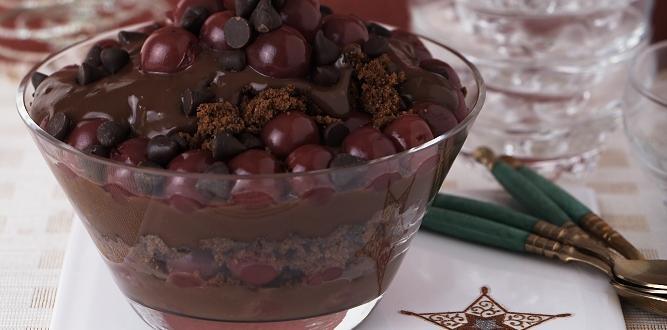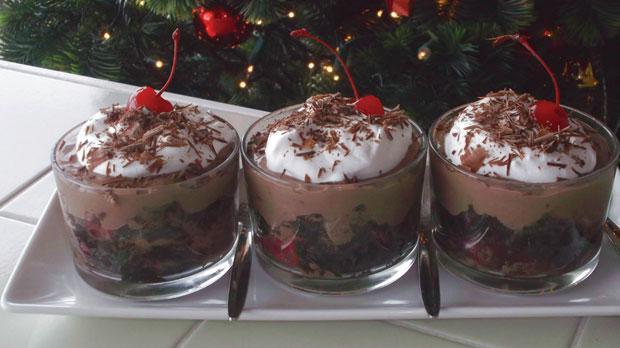The first image is the image on the left, the second image is the image on the right. Given the left and right images, does the statement "In the right image, there are at least three chocolate deserts." hold true? Answer yes or no. Yes. The first image is the image on the left, the second image is the image on the right. For the images displayed, is the sentence "there are two trifles in the image pair" factually correct? Answer yes or no. No. 